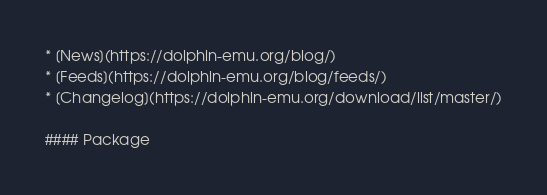Convert code to text. <code><loc_0><loc_0><loc_500><loc_500><_XML_>* [News](https://dolphin-emu.org/blog/)
* [Feeds](https://dolphin-emu.org/blog/feeds/)
* [Changelog](https://dolphin-emu.org/download/list/master/)

#### Package</code> 